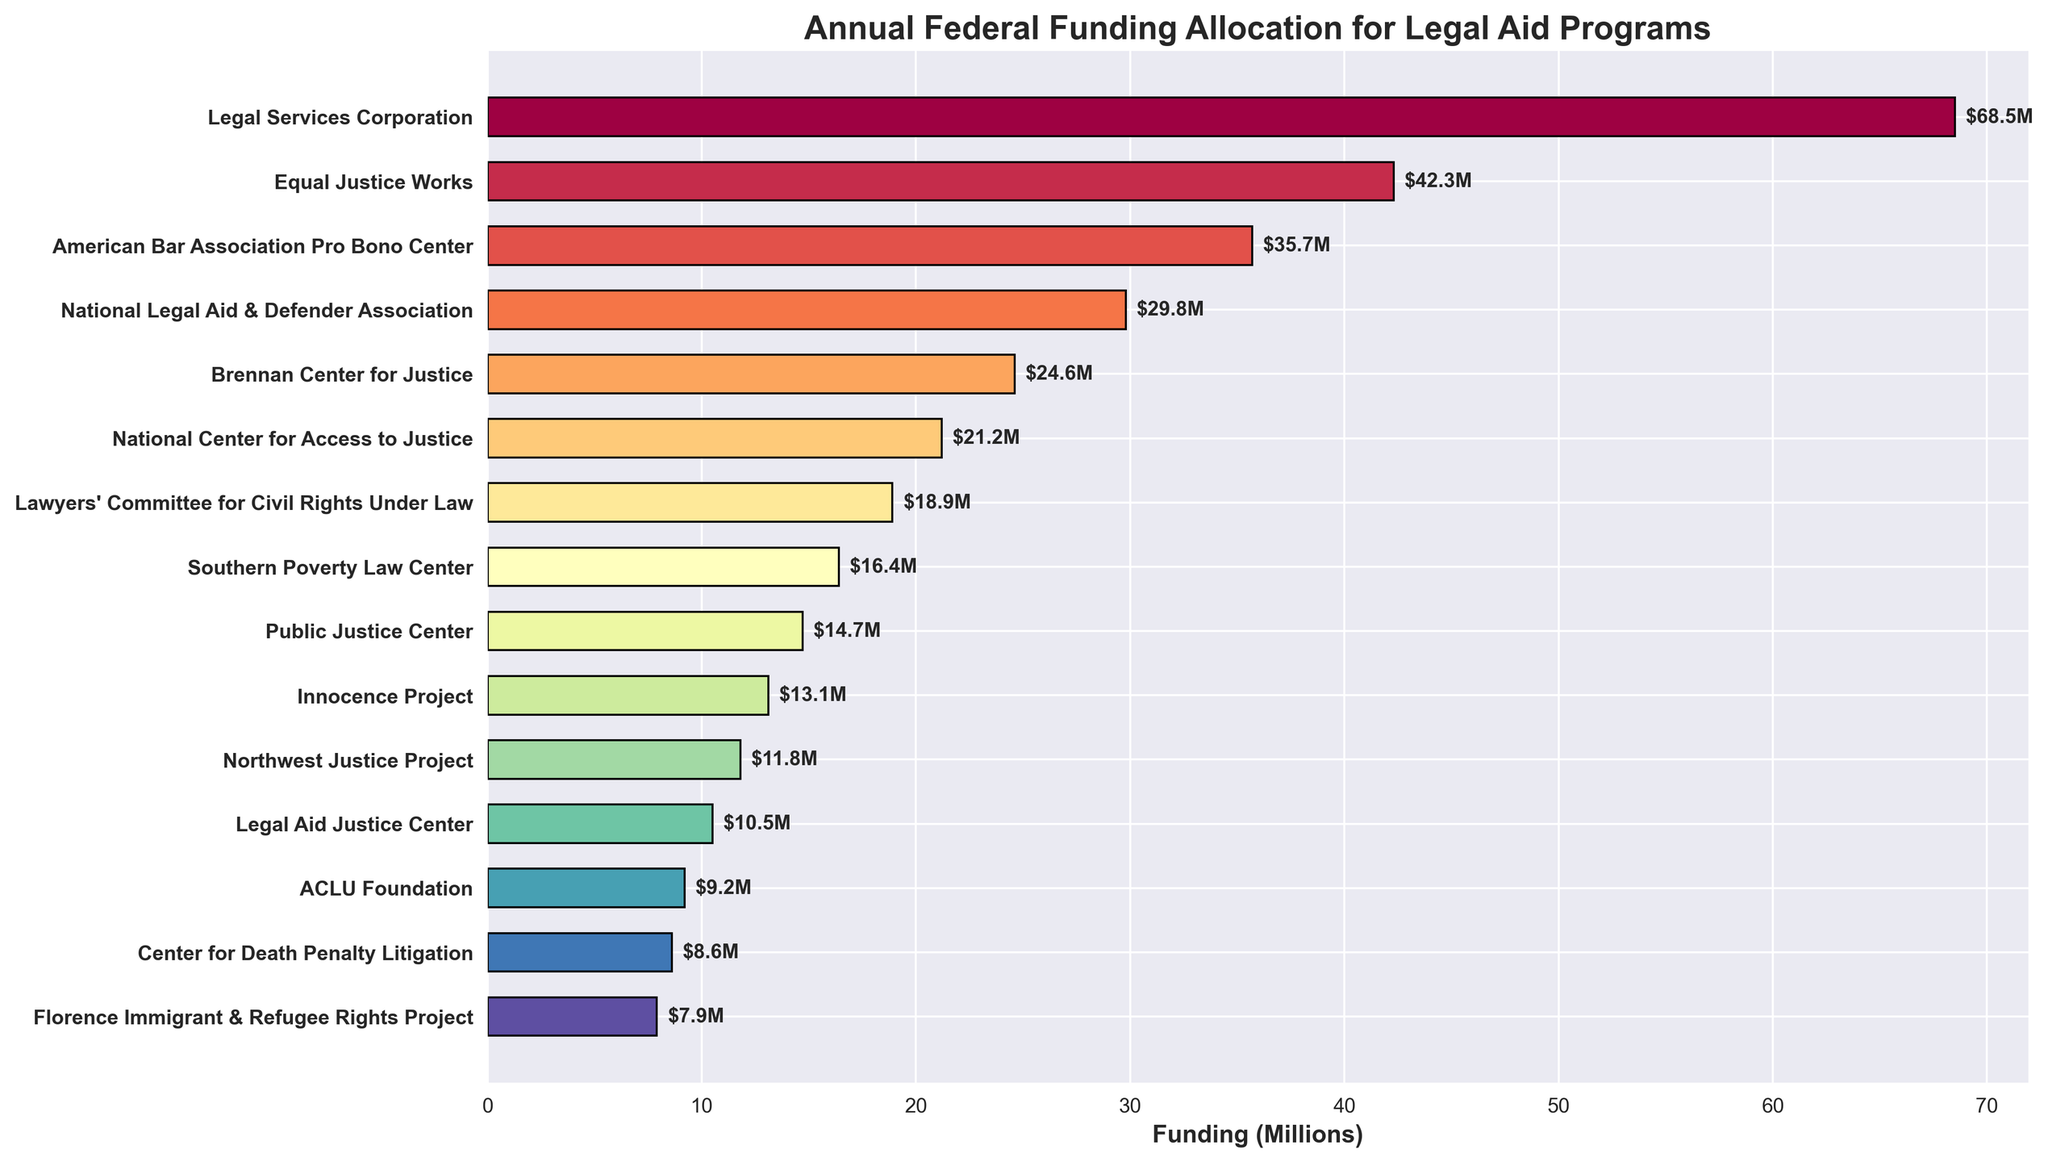How much more federal funding does New York's Legal Services Corporation receive compared to Virginia's Legal Aid Justice Center? To find this, we should subtract the funding for Virginia's Legal Aid Justice Center from the funding for New York's Legal Services Corporation: 68.5M - 10.5M = 58M
Answer: 58M Which state receives the least federal funding for its legal aid program, and how much do they receive? The figure shows that Arizona's Florence Immigrant & Refugee Rights Project receives the least funding at 7.9M
Answer: Arizona, 7.9M What is the combined federal funding allocation for the top 3 legal aid programs? We need to sum the funding for the top 3 programs: New York (68.5M), California (42.3M), and Texas (35.7M). The total is 68.5M + 42.3M + 35.7M = 146.5M
Answer: 146.5M Which legal aid program is nearly at the midpoint in terms of funding when listed in descending order, and how much funding does it receive? We first list the programs in descending order and then find the midpoint. With 15 programs, the midpoint is around the 8th position (Ohio's Lawyers' Committee for Civil Rights Under Law). Ohio receives 18.9M funding
Answer: Ohio, 18.9M How many legal aid programs receive funding of 20 million or more? From the figure, count the programs with funding 20 million or more: New York (68.5M), California (42.3M), Texas (35.7M), Illinois (29.8M), and Florida (24.6M), Pennsylvania (21.2M). There are 6 programs total
Answer: 6 What is the difference in funding between the legal aid programs in Illinois and Massachusetts? Subtract the funding for Massachusetts from Illinois: 29.8M - 13.1M = 16.7M
Answer: 16.7M Which legal aid program is represented with the shortest bar, and what does it signify? Arizona's Florence Immigrant & Refugee Rights Project has the shortest bar, which signifies the smallest amount of federal funding at 7.9M
Answer: Florence Immigrant & Refugee Rights Project, 7.9M Are there more programs with funding above 20 million or below 10 million? From the figure, count the programs: Above 20 million - 6 programs (New York, California, Texas, Illinois, Florida, Pennsylvania); Below 10 million - 3 programs (New Jersey, North Carolina, Arizona). More programs have funding above 20 million
Answer: Above 20 million How much more funding does New York's Legal Services Corporation receive than the median funding program? To find the median, we list all funding values in order and choose the middle one. With 15 values, the 8th value is 18.9M (Ohio). New York's Legal Services Corporation's funding is 68.5M. 68.5M - 18.9M = 49.6M more
Answer: 49.6M What is the average federal funding allocated per legal aid program across all states listed? Sum all funding values and divide by the number of programs: (68.5 + 42.3 + 35.7 + 29.8 + 24.6 + 21.2 + 18.9 + 16.4 + 14.7 + 13.1 + 11.8 + 10.5 + 9.2 + 8.6 + 7.9) = 333.2M; 333.2M / 15 ≈ 22.2M
Answer: 22.2M 